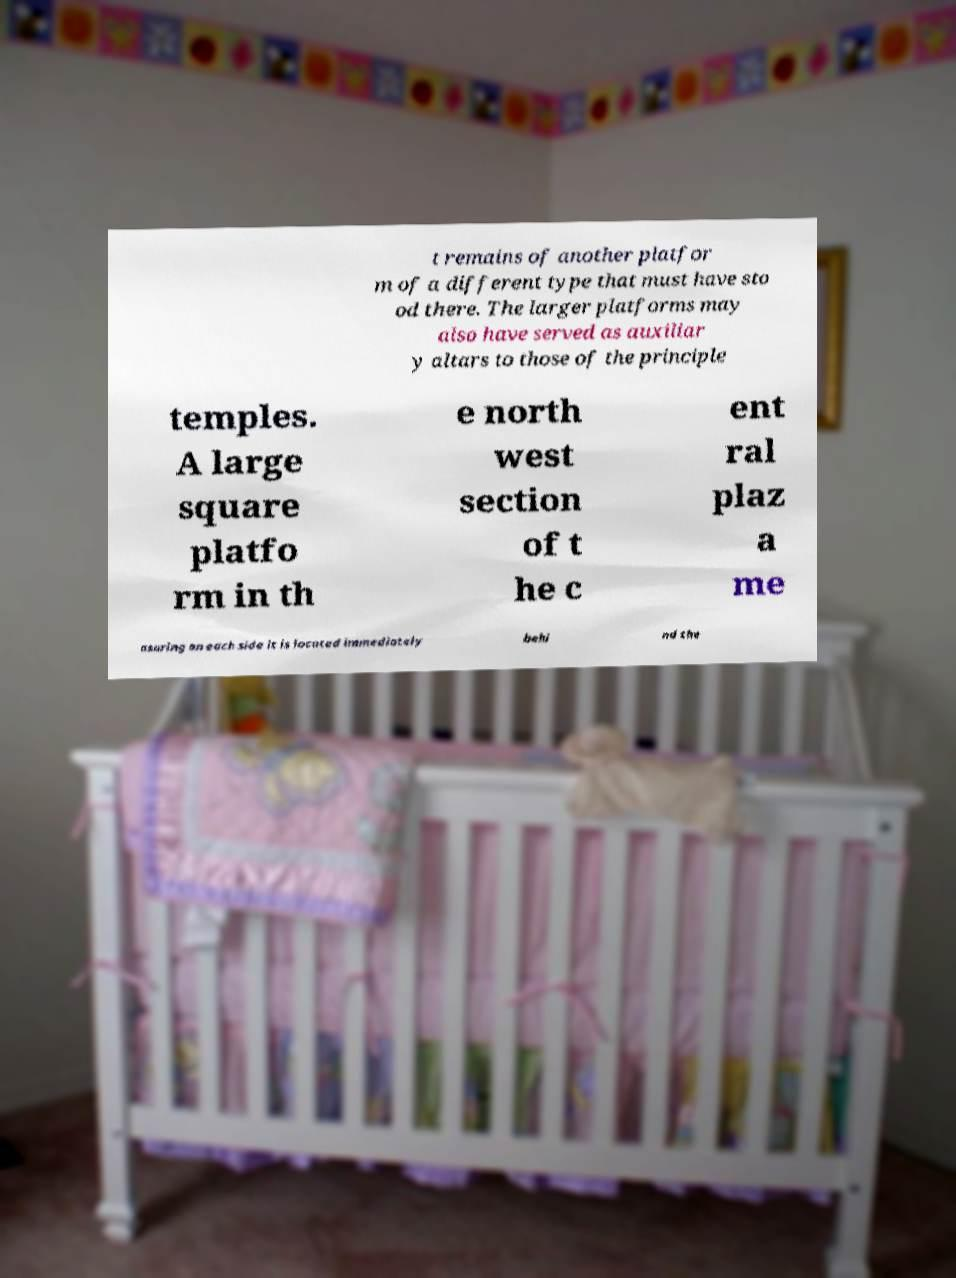There's text embedded in this image that I need extracted. Can you transcribe it verbatim? t remains of another platfor m of a different type that must have sto od there. The larger platforms may also have served as auxiliar y altars to those of the principle temples. A large square platfo rm in th e north west section of t he c ent ral plaz a me asuring on each side it is located immediately behi nd the 